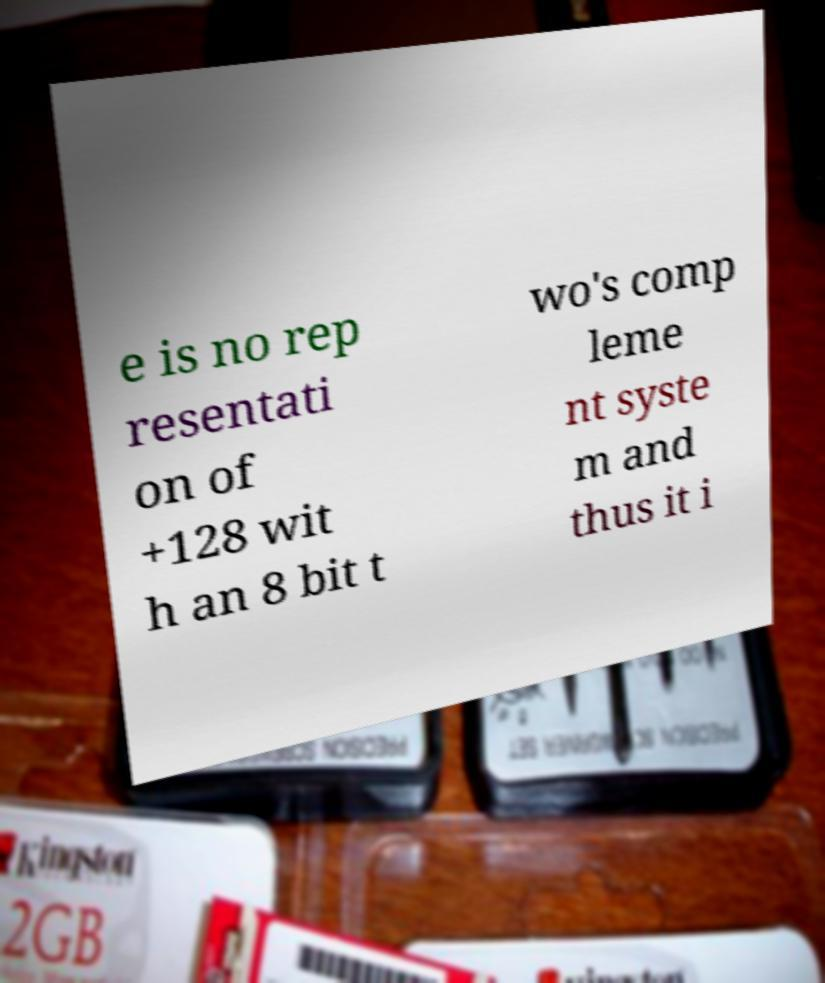Please identify and transcribe the text found in this image. e is no rep resentati on of +128 wit h an 8 bit t wo's comp leme nt syste m and thus it i 